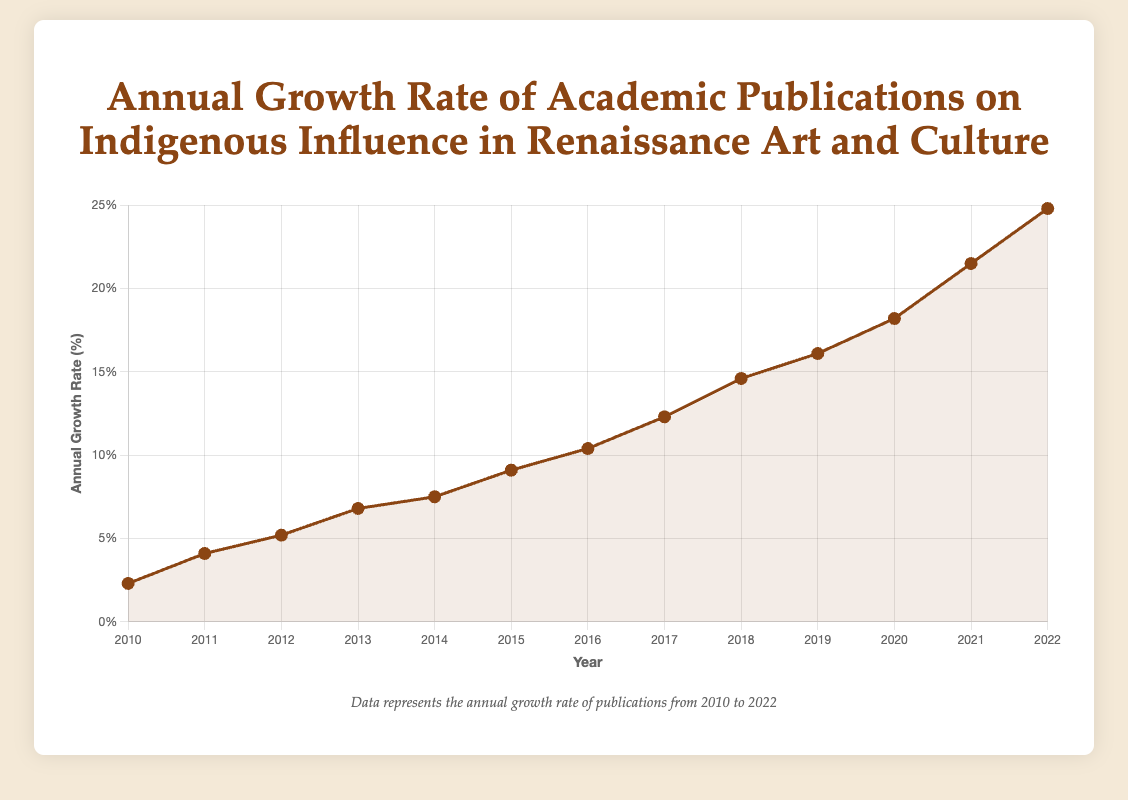What is the general trend in the annual growth rate of academic publications on Indigenous Influence in Renaissance Art and Culture from 2010 to 2022? The general trend can be understood by observing the plot line. From 2010 to 2022, the growth rate continuously increases, indicating a growing interest and recognition in this research area.
Answer: The growth rate increases In which year did the annual growth rate first exceed 10%? We need to examine the point where the growth rate surpasses 10% on the y-axis. This occurs in 2016.
Answer: 2016 By how much did the annual growth rate increase from 2015 to 2016? We calculate the difference in the growth rates for the years 2015 and 2016. The growth rate in 2015 was 9.1% and in 2016 it was 10.4%. So, the increase is 10.4 - 9.1.
Answer: 1.3% Which year observed the highest annual growth rate, and what was the rate? We identify the peak of the plotted line, which indicates the highest growth rate. This occurs in 2022 with the rate of 24.8%.
Answer: 2022 with 24.8% What is the average annual growth rate from 2010 to 2015? We sum the growth rates from 2010 to 2015 and divide by the number of years (6). Sum: 2.3 + 4.1 + 5.2 + 6.8 + 7.5 + 9.1 = 35. Averaging over 6 years: 35/6.
Answer: 5.83% What is the total increase in the annual growth rate from 2010 to 2022? Subtract the growth rate in 2010 from the growth rate in 2022. This is 24.8 - 2.3.
Answer: 22.5% Between which consecutive years was the largest increase in the annual growth rate observed? Calculate the differences between each pair of consecutive years. The largest difference is between 2021 and 2022 (21.5 to 24.8), which is 24.8 - 21.5.
Answer: 2021–2022 What was the median annual growth rate for the years shown in the plot? To find the median, list all the growth rates in ascending order and find the middle value. For 13 data points, the median is the 7th value: 2.3, 4.1, 5.2, 6.8, 7.5, 9.1, 10.4, 12.3, 14.6, 16.1, 18.2, 21.5, 24.8. The median is 10.4.
Answer: 10.4% How does the annual growth rate in 2018 compare to 2020? Compare the values at 2018 and 2020 on the plot. The growth rate was 14.6% in 2018 and 18.2% in 2020. Since 18.2 is greater than 14.6.
Answer: 2020 is higher 